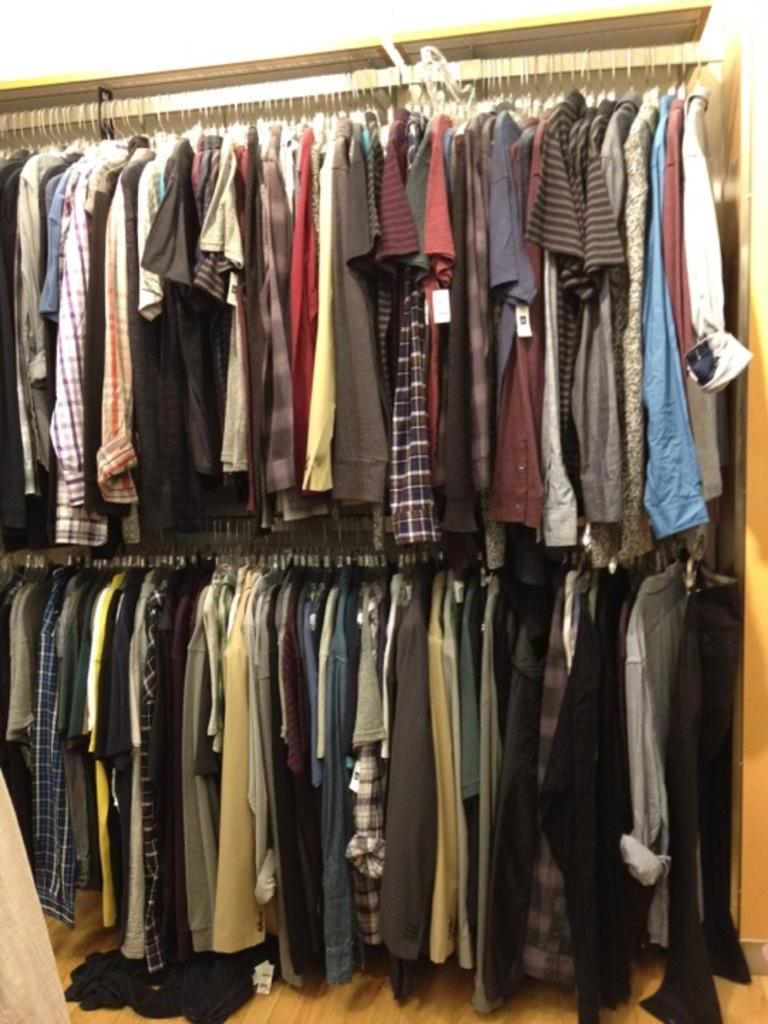What is hanging in the foreground of the image? There are clothes hanging on hangers in the foreground of the image. What part of the image represents the ground? The floor is visible at the bottom of the image. What type of bell can be seen ringing in the image? There is no bell present in the image. What kind of pancake is being flipped in the image? There is no pancake present in the image. 